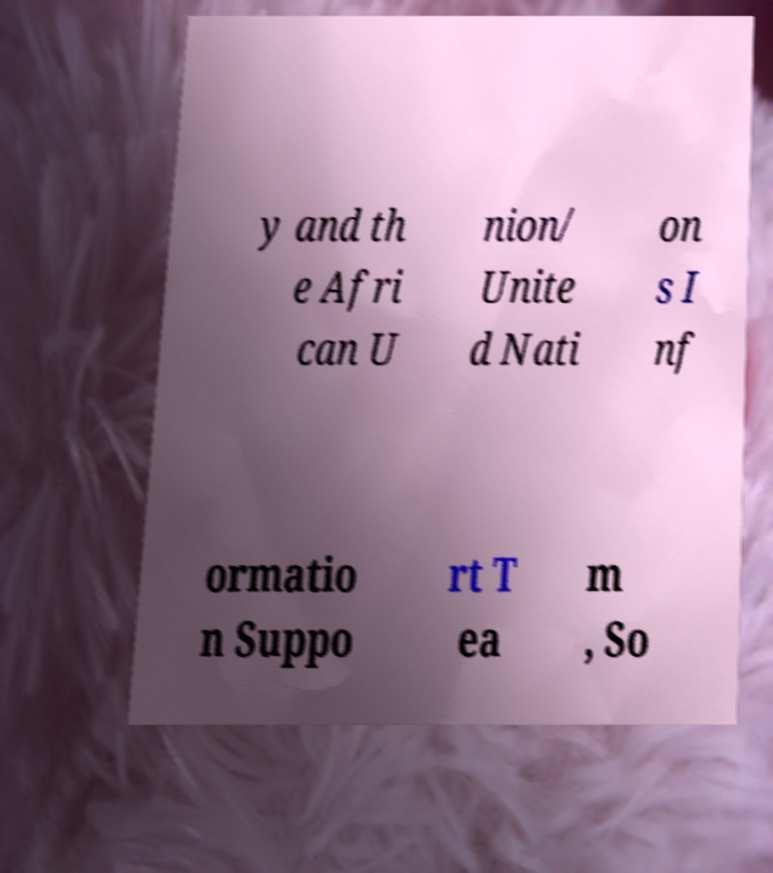For documentation purposes, I need the text within this image transcribed. Could you provide that? y and th e Afri can U nion/ Unite d Nati on s I nf ormatio n Suppo rt T ea m , So 